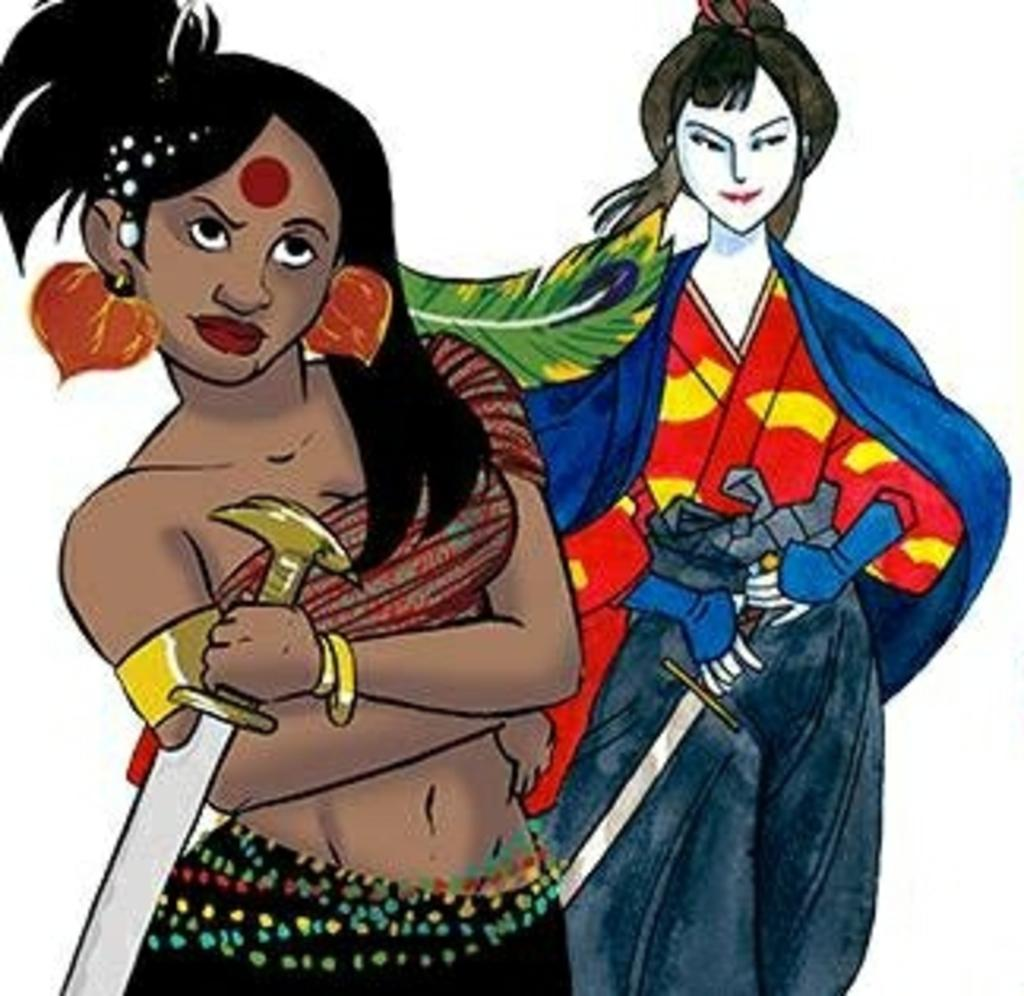What is the main subject of the image? There is a painting in the image. What is depicted in the painting? The painting depicts a woman and a person. What invention can be seen in the painting? There is no invention depicted in the painting; it only shows a woman and a person. Can you describe the sea in the painting? There is no sea present in the painting; it only depicts a woman and a person. 